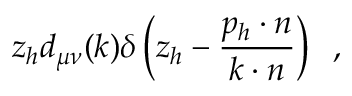Convert formula to latex. <formula><loc_0><loc_0><loc_500><loc_500>z _ { h } d _ { \mu \nu } ( k ) \delta \left ( z _ { h } - \frac { p _ { h } \cdot n } { k \cdot n } \right ) \, ,</formula> 